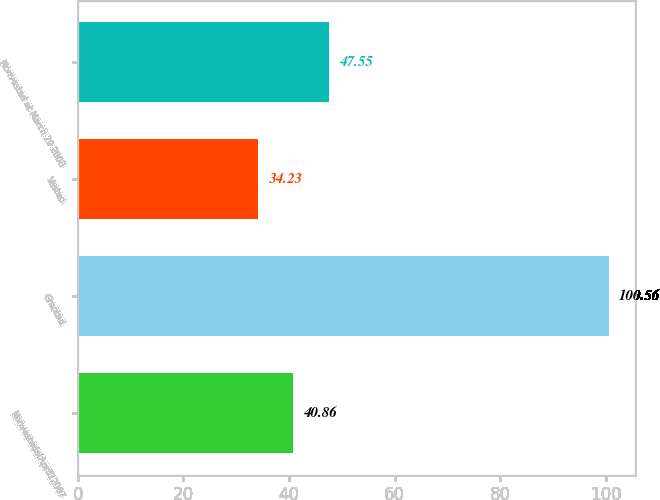Convert chart to OTSL. <chart><loc_0><loc_0><loc_500><loc_500><bar_chart><fcel>NonvestedatApril12007<fcel>Granted<fcel>Vested<fcel>Nonvested at March 29 2008<nl><fcel>40.86<fcel>100.56<fcel>34.23<fcel>47.55<nl></chart> 